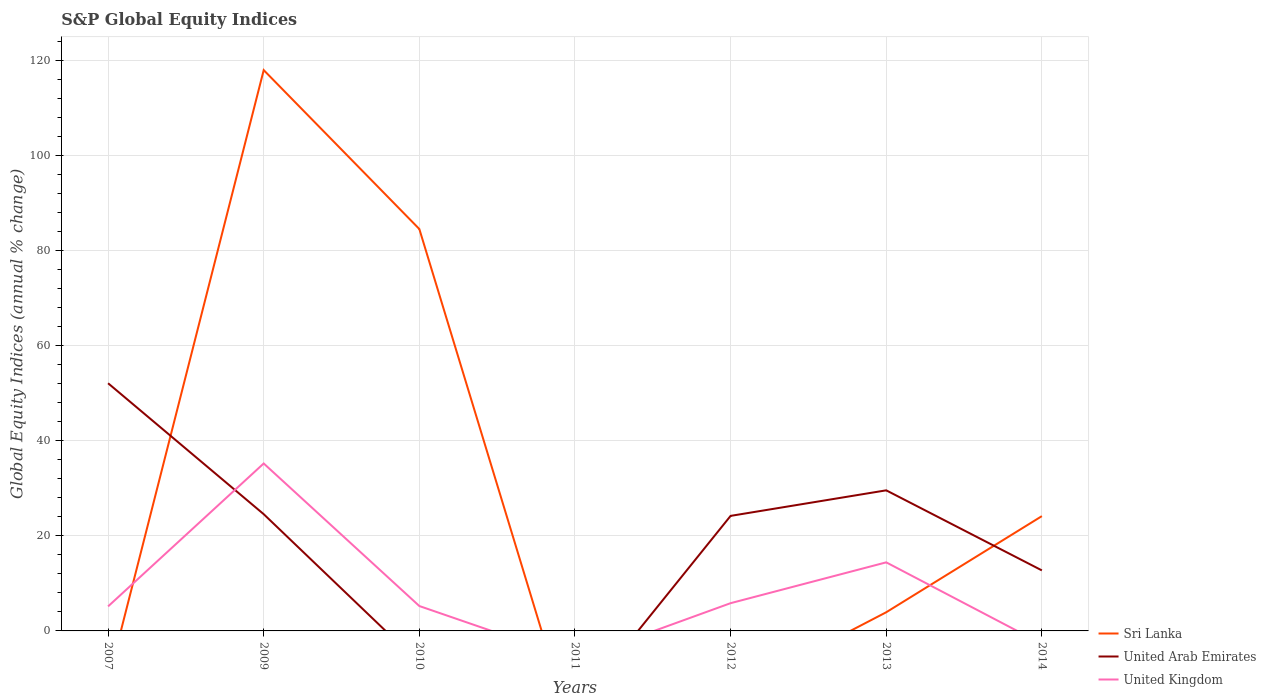How many different coloured lines are there?
Offer a terse response. 3. Is the number of lines equal to the number of legend labels?
Make the answer very short. No. What is the total global equity indices in United Kingdom in the graph?
Give a very brief answer. 30.01. What is the difference between the highest and the second highest global equity indices in United Kingdom?
Give a very brief answer. 35.25. Is the global equity indices in United Arab Emirates strictly greater than the global equity indices in United Kingdom over the years?
Keep it short and to the point. No. How many lines are there?
Your answer should be compact. 3. How many years are there in the graph?
Offer a terse response. 7. Are the values on the major ticks of Y-axis written in scientific E-notation?
Your response must be concise. No. Where does the legend appear in the graph?
Make the answer very short. Bottom right. How many legend labels are there?
Your response must be concise. 3. What is the title of the graph?
Your response must be concise. S&P Global Equity Indices. Does "India" appear as one of the legend labels in the graph?
Your answer should be compact. No. What is the label or title of the Y-axis?
Give a very brief answer. Global Equity Indices (annual % change). What is the Global Equity Indices (annual % change) of United Arab Emirates in 2007?
Provide a succinct answer. 52.13. What is the Global Equity Indices (annual % change) of United Kingdom in 2007?
Your answer should be very brief. 5.16. What is the Global Equity Indices (annual % change) in Sri Lanka in 2009?
Ensure brevity in your answer.  118.05. What is the Global Equity Indices (annual % change) of United Arab Emirates in 2009?
Provide a succinct answer. 24.57. What is the Global Equity Indices (annual % change) of United Kingdom in 2009?
Provide a short and direct response. 35.25. What is the Global Equity Indices (annual % change) in Sri Lanka in 2010?
Offer a very short reply. 84.59. What is the Global Equity Indices (annual % change) in United Arab Emirates in 2010?
Give a very brief answer. 0. What is the Global Equity Indices (annual % change) of United Kingdom in 2010?
Your answer should be compact. 5.24. What is the Global Equity Indices (annual % change) in Sri Lanka in 2011?
Make the answer very short. 0. What is the Global Equity Indices (annual % change) of United Arab Emirates in 2011?
Provide a short and direct response. 0. What is the Global Equity Indices (annual % change) of United Kingdom in 2011?
Provide a short and direct response. 0. What is the Global Equity Indices (annual % change) in United Arab Emirates in 2012?
Offer a terse response. 24.22. What is the Global Equity Indices (annual % change) in United Kingdom in 2012?
Ensure brevity in your answer.  5.84. What is the Global Equity Indices (annual % change) of Sri Lanka in 2013?
Give a very brief answer. 3.93. What is the Global Equity Indices (annual % change) of United Arab Emirates in 2013?
Provide a short and direct response. 29.59. What is the Global Equity Indices (annual % change) in United Kingdom in 2013?
Your answer should be compact. 14.43. What is the Global Equity Indices (annual % change) of Sri Lanka in 2014?
Provide a short and direct response. 24.16. What is the Global Equity Indices (annual % change) of United Arab Emirates in 2014?
Make the answer very short. 12.74. Across all years, what is the maximum Global Equity Indices (annual % change) in Sri Lanka?
Your answer should be very brief. 118.05. Across all years, what is the maximum Global Equity Indices (annual % change) in United Arab Emirates?
Provide a succinct answer. 52.13. Across all years, what is the maximum Global Equity Indices (annual % change) in United Kingdom?
Keep it short and to the point. 35.25. Across all years, what is the minimum Global Equity Indices (annual % change) in Sri Lanka?
Ensure brevity in your answer.  0. Across all years, what is the minimum Global Equity Indices (annual % change) of United Arab Emirates?
Offer a terse response. 0. What is the total Global Equity Indices (annual % change) of Sri Lanka in the graph?
Ensure brevity in your answer.  230.73. What is the total Global Equity Indices (annual % change) in United Arab Emirates in the graph?
Provide a succinct answer. 143.26. What is the total Global Equity Indices (annual % change) in United Kingdom in the graph?
Provide a short and direct response. 65.92. What is the difference between the Global Equity Indices (annual % change) in United Arab Emirates in 2007 and that in 2009?
Keep it short and to the point. 27.56. What is the difference between the Global Equity Indices (annual % change) of United Kingdom in 2007 and that in 2009?
Offer a very short reply. -30.08. What is the difference between the Global Equity Indices (annual % change) in United Kingdom in 2007 and that in 2010?
Your answer should be compact. -0.07. What is the difference between the Global Equity Indices (annual % change) in United Arab Emirates in 2007 and that in 2012?
Offer a terse response. 27.91. What is the difference between the Global Equity Indices (annual % change) in United Kingdom in 2007 and that in 2012?
Your response must be concise. -0.68. What is the difference between the Global Equity Indices (annual % change) of United Arab Emirates in 2007 and that in 2013?
Give a very brief answer. 22.54. What is the difference between the Global Equity Indices (annual % change) of United Kingdom in 2007 and that in 2013?
Give a very brief answer. -9.27. What is the difference between the Global Equity Indices (annual % change) of United Arab Emirates in 2007 and that in 2014?
Provide a succinct answer. 39.39. What is the difference between the Global Equity Indices (annual % change) in Sri Lanka in 2009 and that in 2010?
Ensure brevity in your answer.  33.46. What is the difference between the Global Equity Indices (annual % change) of United Kingdom in 2009 and that in 2010?
Keep it short and to the point. 30.01. What is the difference between the Global Equity Indices (annual % change) of United Arab Emirates in 2009 and that in 2012?
Offer a very short reply. 0.36. What is the difference between the Global Equity Indices (annual % change) in United Kingdom in 2009 and that in 2012?
Offer a very short reply. 29.4. What is the difference between the Global Equity Indices (annual % change) in Sri Lanka in 2009 and that in 2013?
Keep it short and to the point. 114.12. What is the difference between the Global Equity Indices (annual % change) of United Arab Emirates in 2009 and that in 2013?
Give a very brief answer. -5.02. What is the difference between the Global Equity Indices (annual % change) of United Kingdom in 2009 and that in 2013?
Ensure brevity in your answer.  20.81. What is the difference between the Global Equity Indices (annual % change) in Sri Lanka in 2009 and that in 2014?
Your answer should be very brief. 93.89. What is the difference between the Global Equity Indices (annual % change) in United Arab Emirates in 2009 and that in 2014?
Your answer should be very brief. 11.83. What is the difference between the Global Equity Indices (annual % change) in United Kingdom in 2010 and that in 2012?
Ensure brevity in your answer.  -0.6. What is the difference between the Global Equity Indices (annual % change) in Sri Lanka in 2010 and that in 2013?
Make the answer very short. 80.66. What is the difference between the Global Equity Indices (annual % change) in United Kingdom in 2010 and that in 2013?
Provide a succinct answer. -9.2. What is the difference between the Global Equity Indices (annual % change) of Sri Lanka in 2010 and that in 2014?
Make the answer very short. 60.43. What is the difference between the Global Equity Indices (annual % change) in United Arab Emirates in 2012 and that in 2013?
Your answer should be very brief. -5.38. What is the difference between the Global Equity Indices (annual % change) of United Kingdom in 2012 and that in 2013?
Offer a terse response. -8.59. What is the difference between the Global Equity Indices (annual % change) in United Arab Emirates in 2012 and that in 2014?
Give a very brief answer. 11.47. What is the difference between the Global Equity Indices (annual % change) of Sri Lanka in 2013 and that in 2014?
Your response must be concise. -20.23. What is the difference between the Global Equity Indices (annual % change) in United Arab Emirates in 2013 and that in 2014?
Make the answer very short. 16.85. What is the difference between the Global Equity Indices (annual % change) in United Arab Emirates in 2007 and the Global Equity Indices (annual % change) in United Kingdom in 2009?
Your answer should be very brief. 16.89. What is the difference between the Global Equity Indices (annual % change) in United Arab Emirates in 2007 and the Global Equity Indices (annual % change) in United Kingdom in 2010?
Provide a short and direct response. 46.89. What is the difference between the Global Equity Indices (annual % change) of United Arab Emirates in 2007 and the Global Equity Indices (annual % change) of United Kingdom in 2012?
Your answer should be compact. 46.29. What is the difference between the Global Equity Indices (annual % change) of United Arab Emirates in 2007 and the Global Equity Indices (annual % change) of United Kingdom in 2013?
Provide a succinct answer. 37.7. What is the difference between the Global Equity Indices (annual % change) of Sri Lanka in 2009 and the Global Equity Indices (annual % change) of United Kingdom in 2010?
Your response must be concise. 112.81. What is the difference between the Global Equity Indices (annual % change) of United Arab Emirates in 2009 and the Global Equity Indices (annual % change) of United Kingdom in 2010?
Provide a short and direct response. 19.34. What is the difference between the Global Equity Indices (annual % change) in Sri Lanka in 2009 and the Global Equity Indices (annual % change) in United Arab Emirates in 2012?
Give a very brief answer. 93.83. What is the difference between the Global Equity Indices (annual % change) in Sri Lanka in 2009 and the Global Equity Indices (annual % change) in United Kingdom in 2012?
Provide a short and direct response. 112.21. What is the difference between the Global Equity Indices (annual % change) in United Arab Emirates in 2009 and the Global Equity Indices (annual % change) in United Kingdom in 2012?
Your answer should be very brief. 18.73. What is the difference between the Global Equity Indices (annual % change) in Sri Lanka in 2009 and the Global Equity Indices (annual % change) in United Arab Emirates in 2013?
Provide a succinct answer. 88.46. What is the difference between the Global Equity Indices (annual % change) of Sri Lanka in 2009 and the Global Equity Indices (annual % change) of United Kingdom in 2013?
Your answer should be compact. 103.62. What is the difference between the Global Equity Indices (annual % change) in United Arab Emirates in 2009 and the Global Equity Indices (annual % change) in United Kingdom in 2013?
Ensure brevity in your answer.  10.14. What is the difference between the Global Equity Indices (annual % change) in Sri Lanka in 2009 and the Global Equity Indices (annual % change) in United Arab Emirates in 2014?
Offer a very short reply. 105.31. What is the difference between the Global Equity Indices (annual % change) of Sri Lanka in 2010 and the Global Equity Indices (annual % change) of United Arab Emirates in 2012?
Make the answer very short. 60.37. What is the difference between the Global Equity Indices (annual % change) in Sri Lanka in 2010 and the Global Equity Indices (annual % change) in United Kingdom in 2012?
Offer a very short reply. 78.75. What is the difference between the Global Equity Indices (annual % change) of Sri Lanka in 2010 and the Global Equity Indices (annual % change) of United Arab Emirates in 2013?
Your response must be concise. 55. What is the difference between the Global Equity Indices (annual % change) of Sri Lanka in 2010 and the Global Equity Indices (annual % change) of United Kingdom in 2013?
Provide a succinct answer. 70.16. What is the difference between the Global Equity Indices (annual % change) of Sri Lanka in 2010 and the Global Equity Indices (annual % change) of United Arab Emirates in 2014?
Your answer should be compact. 71.85. What is the difference between the Global Equity Indices (annual % change) in United Arab Emirates in 2012 and the Global Equity Indices (annual % change) in United Kingdom in 2013?
Offer a terse response. 9.78. What is the difference between the Global Equity Indices (annual % change) of Sri Lanka in 2013 and the Global Equity Indices (annual % change) of United Arab Emirates in 2014?
Provide a short and direct response. -8.81. What is the average Global Equity Indices (annual % change) of Sri Lanka per year?
Your response must be concise. 32.96. What is the average Global Equity Indices (annual % change) of United Arab Emirates per year?
Keep it short and to the point. 20.47. What is the average Global Equity Indices (annual % change) of United Kingdom per year?
Your response must be concise. 9.42. In the year 2007, what is the difference between the Global Equity Indices (annual % change) in United Arab Emirates and Global Equity Indices (annual % change) in United Kingdom?
Give a very brief answer. 46.97. In the year 2009, what is the difference between the Global Equity Indices (annual % change) in Sri Lanka and Global Equity Indices (annual % change) in United Arab Emirates?
Make the answer very short. 93.47. In the year 2009, what is the difference between the Global Equity Indices (annual % change) of Sri Lanka and Global Equity Indices (annual % change) of United Kingdom?
Give a very brief answer. 82.8. In the year 2009, what is the difference between the Global Equity Indices (annual % change) of United Arab Emirates and Global Equity Indices (annual % change) of United Kingdom?
Provide a short and direct response. -10.67. In the year 2010, what is the difference between the Global Equity Indices (annual % change) in Sri Lanka and Global Equity Indices (annual % change) in United Kingdom?
Provide a succinct answer. 79.35. In the year 2012, what is the difference between the Global Equity Indices (annual % change) in United Arab Emirates and Global Equity Indices (annual % change) in United Kingdom?
Provide a short and direct response. 18.37. In the year 2013, what is the difference between the Global Equity Indices (annual % change) in Sri Lanka and Global Equity Indices (annual % change) in United Arab Emirates?
Provide a succinct answer. -25.67. In the year 2013, what is the difference between the Global Equity Indices (annual % change) in Sri Lanka and Global Equity Indices (annual % change) in United Kingdom?
Offer a very short reply. -10.51. In the year 2013, what is the difference between the Global Equity Indices (annual % change) in United Arab Emirates and Global Equity Indices (annual % change) in United Kingdom?
Make the answer very short. 15.16. In the year 2014, what is the difference between the Global Equity Indices (annual % change) of Sri Lanka and Global Equity Indices (annual % change) of United Arab Emirates?
Make the answer very short. 11.42. What is the ratio of the Global Equity Indices (annual % change) of United Arab Emirates in 2007 to that in 2009?
Give a very brief answer. 2.12. What is the ratio of the Global Equity Indices (annual % change) in United Kingdom in 2007 to that in 2009?
Give a very brief answer. 0.15. What is the ratio of the Global Equity Indices (annual % change) in United Kingdom in 2007 to that in 2010?
Your answer should be compact. 0.99. What is the ratio of the Global Equity Indices (annual % change) of United Arab Emirates in 2007 to that in 2012?
Your answer should be compact. 2.15. What is the ratio of the Global Equity Indices (annual % change) in United Kingdom in 2007 to that in 2012?
Your answer should be very brief. 0.88. What is the ratio of the Global Equity Indices (annual % change) of United Arab Emirates in 2007 to that in 2013?
Offer a very short reply. 1.76. What is the ratio of the Global Equity Indices (annual % change) in United Kingdom in 2007 to that in 2013?
Your response must be concise. 0.36. What is the ratio of the Global Equity Indices (annual % change) in United Arab Emirates in 2007 to that in 2014?
Your answer should be very brief. 4.09. What is the ratio of the Global Equity Indices (annual % change) of Sri Lanka in 2009 to that in 2010?
Your answer should be compact. 1.4. What is the ratio of the Global Equity Indices (annual % change) in United Kingdom in 2009 to that in 2010?
Offer a terse response. 6.73. What is the ratio of the Global Equity Indices (annual % change) in United Arab Emirates in 2009 to that in 2012?
Your answer should be compact. 1.01. What is the ratio of the Global Equity Indices (annual % change) in United Kingdom in 2009 to that in 2012?
Your answer should be compact. 6.03. What is the ratio of the Global Equity Indices (annual % change) in Sri Lanka in 2009 to that in 2013?
Provide a succinct answer. 30.06. What is the ratio of the Global Equity Indices (annual % change) of United Arab Emirates in 2009 to that in 2013?
Offer a terse response. 0.83. What is the ratio of the Global Equity Indices (annual % change) of United Kingdom in 2009 to that in 2013?
Make the answer very short. 2.44. What is the ratio of the Global Equity Indices (annual % change) in Sri Lanka in 2009 to that in 2014?
Give a very brief answer. 4.89. What is the ratio of the Global Equity Indices (annual % change) in United Arab Emirates in 2009 to that in 2014?
Keep it short and to the point. 1.93. What is the ratio of the Global Equity Indices (annual % change) in United Kingdom in 2010 to that in 2012?
Your answer should be very brief. 0.9. What is the ratio of the Global Equity Indices (annual % change) of Sri Lanka in 2010 to that in 2013?
Offer a terse response. 21.54. What is the ratio of the Global Equity Indices (annual % change) of United Kingdom in 2010 to that in 2013?
Offer a very short reply. 0.36. What is the ratio of the Global Equity Indices (annual % change) in Sri Lanka in 2010 to that in 2014?
Provide a succinct answer. 3.5. What is the ratio of the Global Equity Indices (annual % change) of United Arab Emirates in 2012 to that in 2013?
Provide a succinct answer. 0.82. What is the ratio of the Global Equity Indices (annual % change) in United Kingdom in 2012 to that in 2013?
Offer a very short reply. 0.4. What is the ratio of the Global Equity Indices (annual % change) of United Arab Emirates in 2012 to that in 2014?
Your answer should be very brief. 1.9. What is the ratio of the Global Equity Indices (annual % change) of Sri Lanka in 2013 to that in 2014?
Offer a terse response. 0.16. What is the ratio of the Global Equity Indices (annual % change) of United Arab Emirates in 2013 to that in 2014?
Your answer should be compact. 2.32. What is the difference between the highest and the second highest Global Equity Indices (annual % change) of Sri Lanka?
Provide a succinct answer. 33.46. What is the difference between the highest and the second highest Global Equity Indices (annual % change) in United Arab Emirates?
Your response must be concise. 22.54. What is the difference between the highest and the second highest Global Equity Indices (annual % change) of United Kingdom?
Your answer should be very brief. 20.81. What is the difference between the highest and the lowest Global Equity Indices (annual % change) in Sri Lanka?
Ensure brevity in your answer.  118.05. What is the difference between the highest and the lowest Global Equity Indices (annual % change) of United Arab Emirates?
Provide a succinct answer. 52.13. What is the difference between the highest and the lowest Global Equity Indices (annual % change) in United Kingdom?
Your response must be concise. 35.25. 